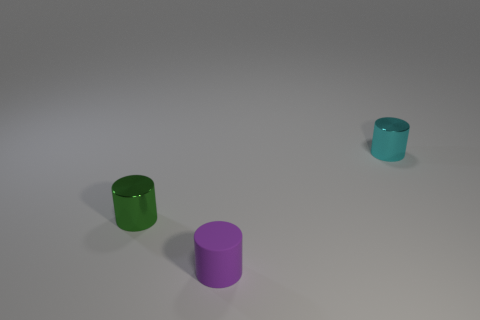Are there any tiny shiny cylinders?
Provide a succinct answer. Yes. What color is the other metallic object that is the same shape as the cyan metallic object?
Provide a short and direct response. Green. Is the color of the cylinder behind the small green cylinder the same as the rubber thing?
Make the answer very short. No. Is the rubber cylinder the same size as the green cylinder?
Your response must be concise. Yes. What is the shape of the other tiny thing that is the same material as the small green object?
Offer a very short reply. Cylinder. What number of other things are the same shape as the green metallic thing?
Offer a very short reply. 2. There is a metallic thing that is behind the shiny object in front of the cylinder that is on the right side of the purple cylinder; what is its shape?
Provide a succinct answer. Cylinder. How many cylinders are small purple objects or small metallic things?
Provide a succinct answer. 3. There is a tiny object behind the green thing; is there a green cylinder that is on the right side of it?
Make the answer very short. No. Is there anything else that has the same material as the tiny purple cylinder?
Offer a terse response. No. 